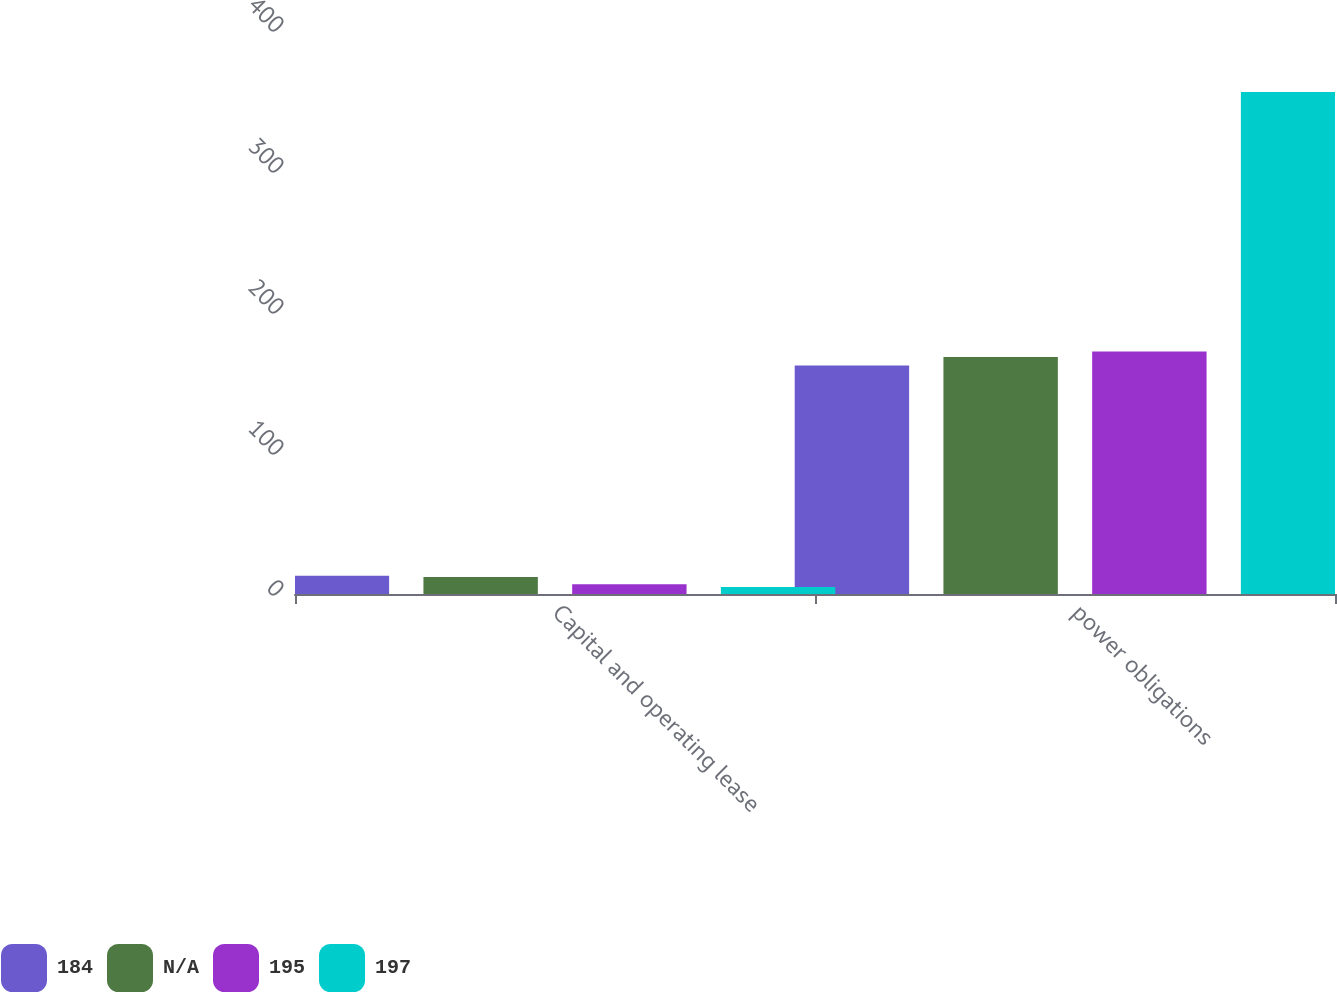Convert chart to OTSL. <chart><loc_0><loc_0><loc_500><loc_500><stacked_bar_chart><ecel><fcel>Capital and operating lease<fcel>power obligations<nl><fcel>184<fcel>13<fcel>162<nl><fcel>nan<fcel>12<fcel>168<nl><fcel>195<fcel>7<fcel>172<nl><fcel>197<fcel>5<fcel>356<nl></chart> 